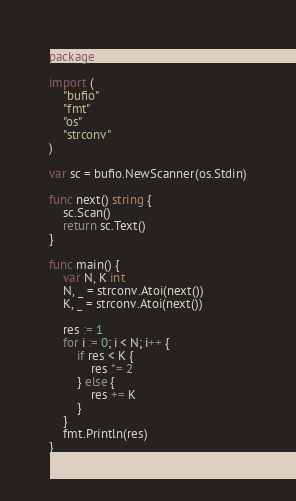Convert code to text. <code><loc_0><loc_0><loc_500><loc_500><_Go_>package main

import (
	"bufio"
	"fmt"
	"os"
	"strconv"
)

var sc = bufio.NewScanner(os.Stdin)

func next() string {
	sc.Scan()
	return sc.Text()
}

func main() {
	var N, K int
	N, _ = strconv.Atoi(next())
	K, _ = strconv.Atoi(next())
	
	res := 1
	for i := 0; i < N; i++ {
		if res < K {
			res *= 2
		} else {
			res += K
		}
	}
	fmt.Println(res)
}</code> 